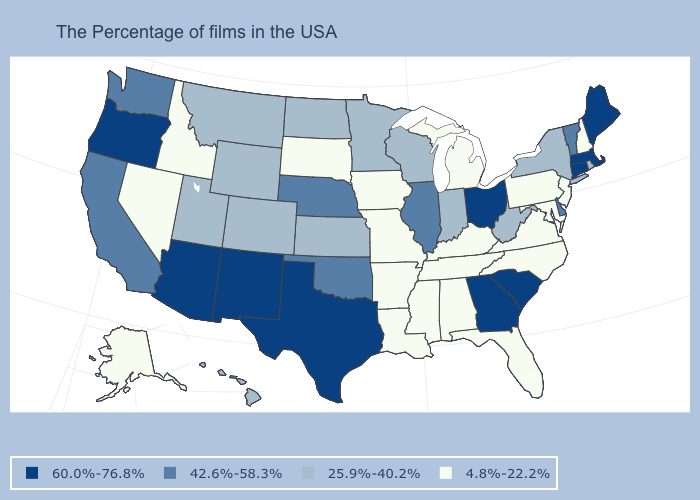What is the highest value in states that border Idaho?
Quick response, please. 60.0%-76.8%. Is the legend a continuous bar?
Short answer required. No. Does Texas have the same value as Ohio?
Short answer required. Yes. What is the value of Pennsylvania?
Concise answer only. 4.8%-22.2%. Does Ohio have the highest value in the USA?
Write a very short answer. Yes. What is the value of Wyoming?
Give a very brief answer. 25.9%-40.2%. What is the value of New Mexico?
Be succinct. 60.0%-76.8%. Name the states that have a value in the range 60.0%-76.8%?
Concise answer only. Maine, Massachusetts, Connecticut, South Carolina, Ohio, Georgia, Texas, New Mexico, Arizona, Oregon. Which states have the highest value in the USA?
Write a very short answer. Maine, Massachusetts, Connecticut, South Carolina, Ohio, Georgia, Texas, New Mexico, Arizona, Oregon. What is the value of Georgia?
Give a very brief answer. 60.0%-76.8%. What is the highest value in the MidWest ?
Write a very short answer. 60.0%-76.8%. What is the lowest value in states that border Wyoming?
Quick response, please. 4.8%-22.2%. What is the lowest value in the MidWest?
Quick response, please. 4.8%-22.2%. Name the states that have a value in the range 42.6%-58.3%?
Quick response, please. Vermont, Delaware, Illinois, Nebraska, Oklahoma, California, Washington. What is the highest value in the West ?
Short answer required. 60.0%-76.8%. 